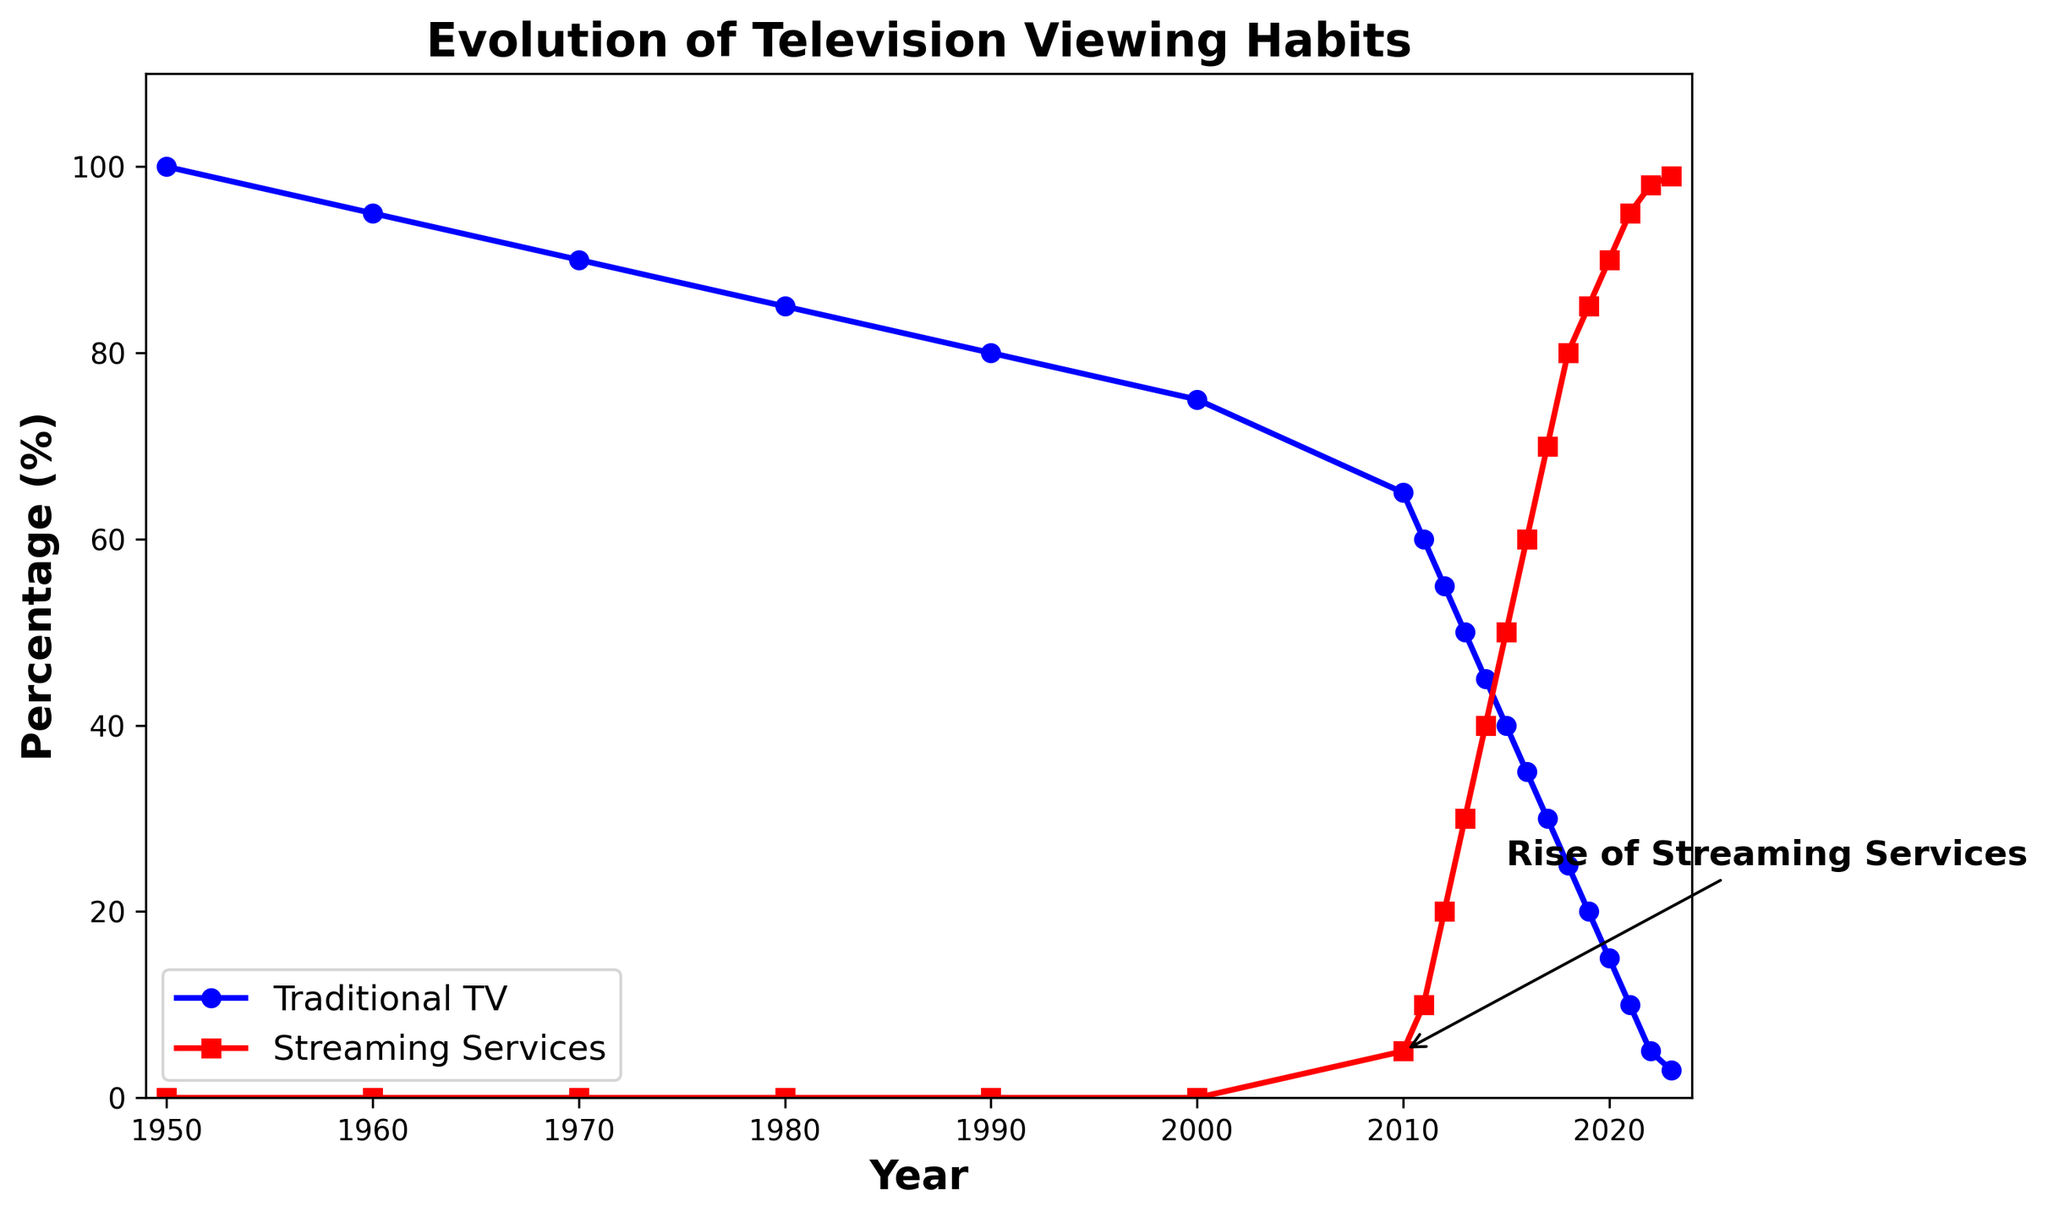When did streaming services reach 50% usage? To determine when streaming services first reach 50% usage, scan along the red line and note that it hits 50% in the year 2015.
Answer: 2015 How many years after the inflection point did streaming services surpass traditional TV in percentage? The inflection point occurs in 2010. Streaming services surpass traditional TV around 2015. We subtract 2010 from 2015 which gives us 5 years.
Answer: 5 years At what year did traditional TV fall below 50%? To find the year traditional TV falls below 50%, track the blue line downward and observe it crosses 50% in 2012.
Answer: 2012 What is the percentage difference in usage between traditional TV and streaming services in 2020? In 2020, traditional TV usage is 15% and streaming services usage is 90%. The difference is calculated by subtracting 15 from 90, resulting in 75%.
Answer: 75% Which type of viewing habit experienced a steeper decline initially, and during which period? Traditional TV shows a consistent and steeper initial decline from 1950 to 2010, compared to streaming services, which start rising only after 2010.
Answer: Traditional TV, 1950 to 2010 When did the percentages of traditional TV and streaming services equalize? Equalization occurs where the two lines intersect. By observing the graph, we see the intersection is around 2014.
Answer: Around 2014 How did the percentage of traditional TV usage change from 2000 to 2010? Traditional TV usage drops from 75% in 2000 to 65% in 2010. The change is calculated as 75% - 65%, equating to a 10% decrease.
Answer: Decrease by 10% What percentage of usage did streaming services have by the end of the timeline? By the last data point, 2023, streaming services have reached a near saturation usage of 99%.
Answer: 99% What is the total decline in traditional TV viewership from 1950 to 2023? Traditional TV starts at 100% in 1950 and drops to 3% by 2023. The total decline is 100% - 3% = 97%.
Answer: 97% Which era saw the fastest increase in streaming services adoption and what was its percentage increase? The fastest increase is observed between 2010 and 2015 when streaming services rose from 5% to 50%. This is a difference of 50% - 5% = 45%.
Answer: 2010 to 2015, increase by 45% 